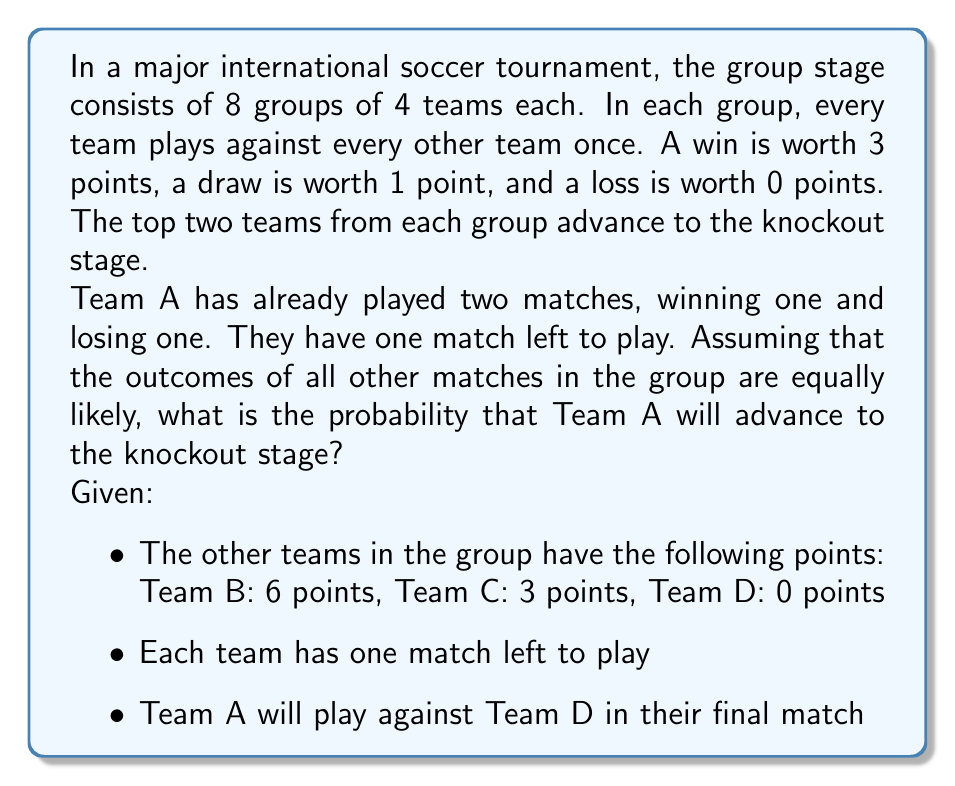Give your solution to this math problem. Let's approach this step-by-step:

1) First, let's calculate Team A's current points:
   Win (1) = 3 points, Loss (1) = 0 points
   Total = 3 points

2) Possible outcomes for Team A's final match:
   Win: probability $\frac{1}{3}$, +3 points
   Draw: probability $\frac{1}{3}$, +1 point
   Loss: probability $\frac{1}{3}$, +0 points

3) Possible final point totals for Team A:
   Win: 3 + 3 = 6 points
   Draw: 3 + 1 = 4 points
   Loss: 3 + 0 = 3 points

4) Now, let's consider the other teams:
   Team B: Already has 6 points, guaranteed to advance
   Team C: Has 3 points, one match left
   Team D: Has 0 points, will play against Team A

5) For Team A to advance, they need to:
   a) Finish with more points than Team C, or
   b) Finish with the same points as Team C and have a better goal difference (we'll assume this is a 50-50 chance if points are tied)

6) Let's calculate the probability for each scenario:

   If Team A wins (6 points):
   - They advance regardless of Team C's result
   Probability = $\frac{1}{3}$

   If Team A draws (4 points):
   - They advance if Team C loses
   - They have a 50% chance of advancing if Team C draws
   Probability = $\frac{1}{3} \cdot (\frac{1}{3} + \frac{1}{2} \cdot \frac{1}{3}) = \frac{1}{6}$

   If Team A loses (3 points):
   - They can only advance if Team C loses and they win the tiebreaker
   Probability = $\frac{1}{3} \cdot \frac{1}{3} \cdot \frac{1}{2} = \frac{1}{18}$

7) Total probability of advancing:
   $$P(\text{advancing}) = \frac{1}{3} + \frac{1}{6} + \frac{1}{18} = \frac{6}{18} + \frac{3}{18} + \frac{1}{18} = \frac{10}{18} = \frac{5}{9}$$
Answer: The probability that Team A will advance to the knockout stage is $\frac{5}{9}$ or approximately 0.5556 or 55.56%. 